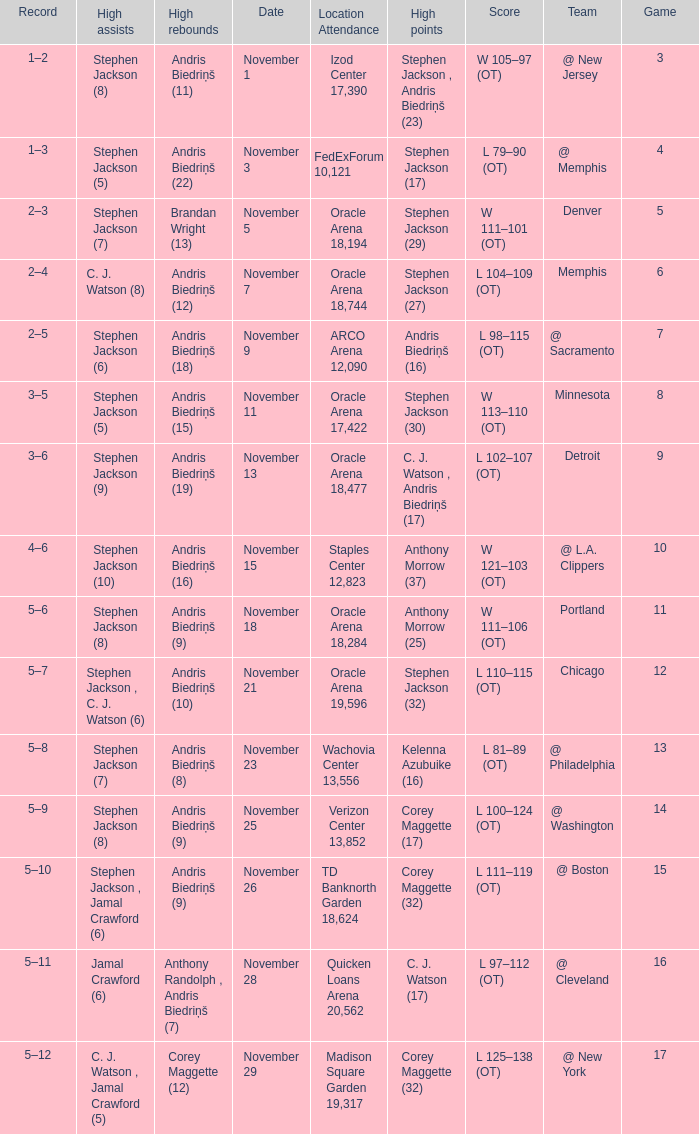What was the game number that was played on November 15? 10.0. 